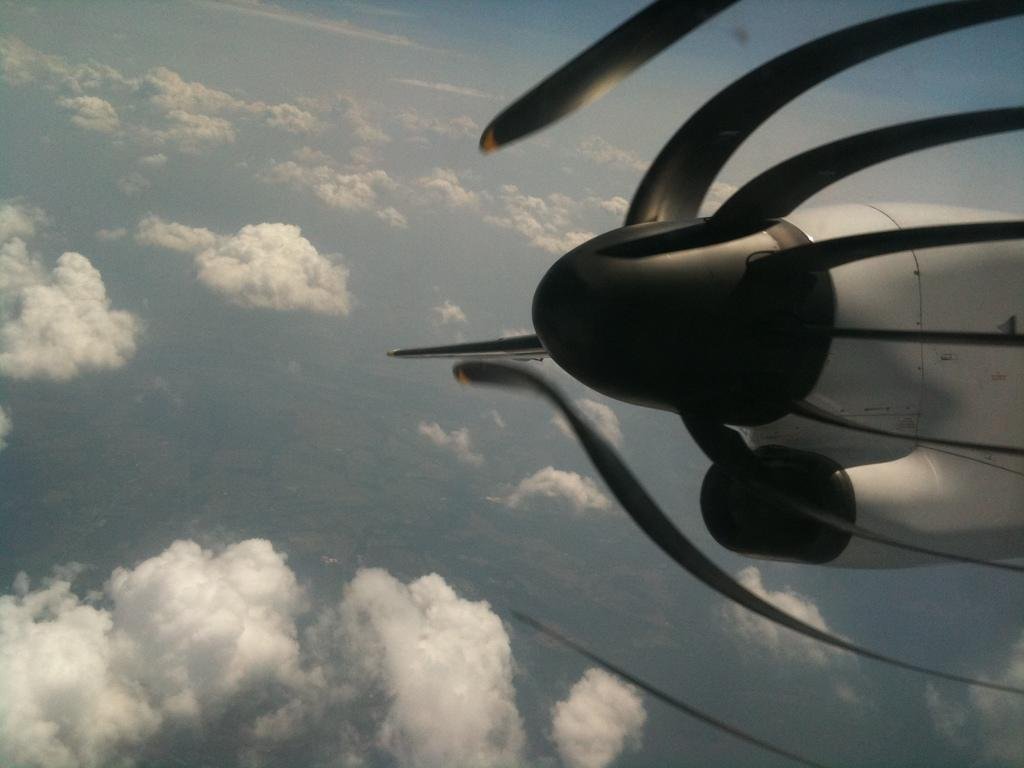What is the main subject of the image? The main subject of the image is the propeller of an airplane. Where is the propeller located in the image? The propeller is in the sky. What can be seen at the bottom of the image? There are clouds at the bottom of the image. What type of clam is sitting on the table in the image? There is no clam or table present in the image. Who is the authority figure in the image? There is no authority figure present in the image. 